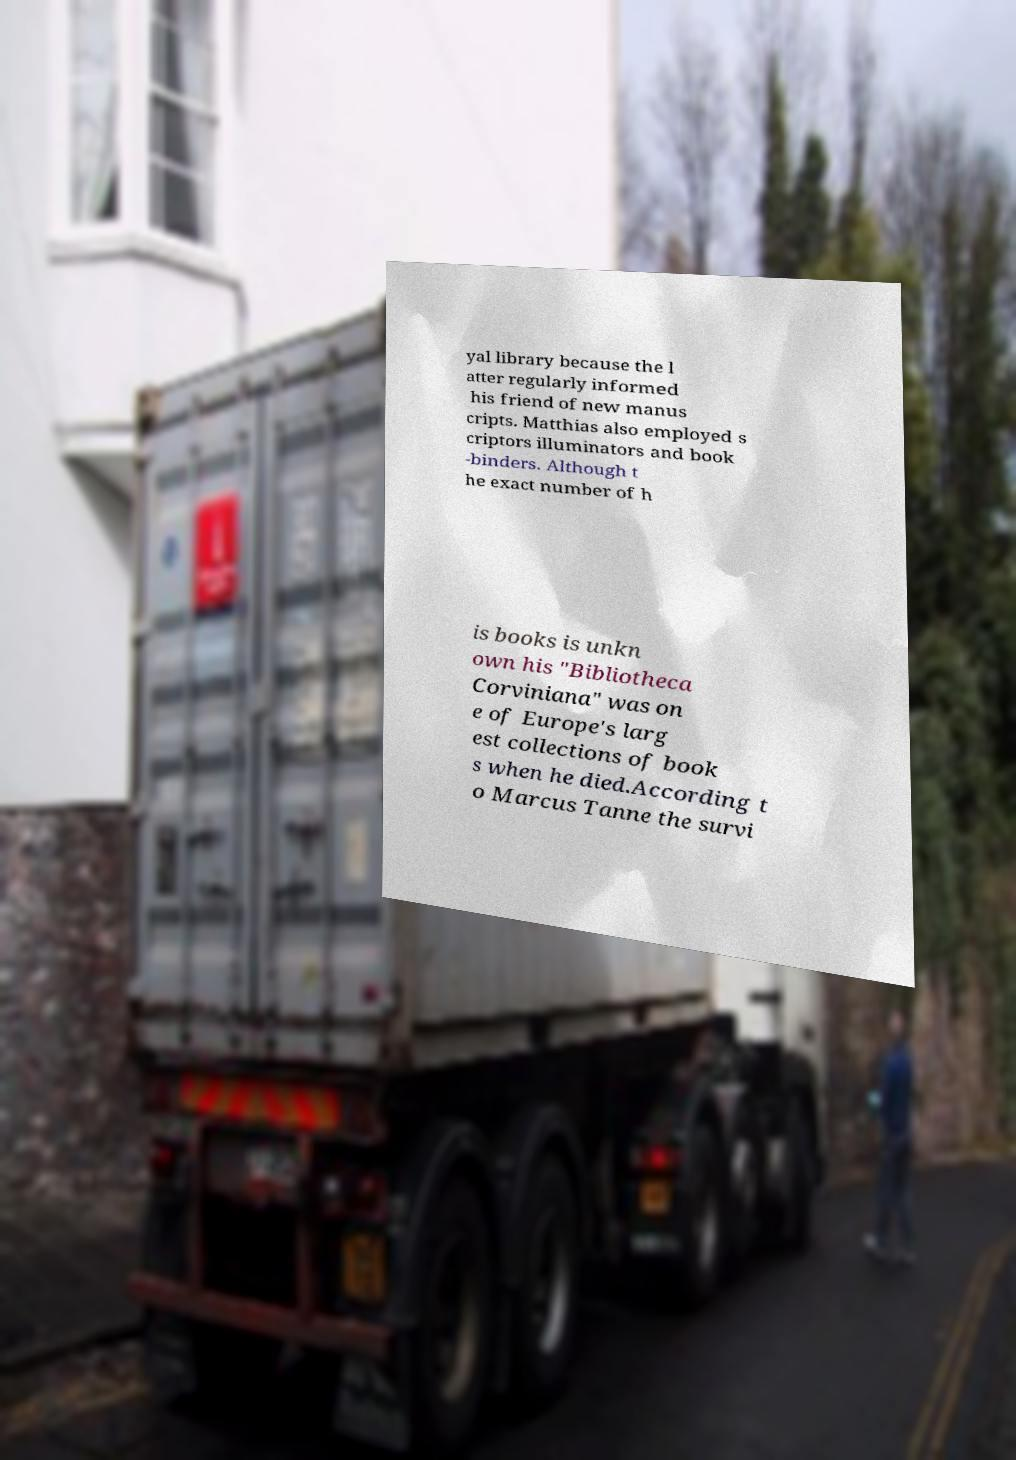Please read and relay the text visible in this image. What does it say? yal library because the l atter regularly informed his friend of new manus cripts. Matthias also employed s criptors illuminators and book -binders. Although t he exact number of h is books is unkn own his "Bibliotheca Corviniana" was on e of Europe's larg est collections of book s when he died.According t o Marcus Tanne the survi 